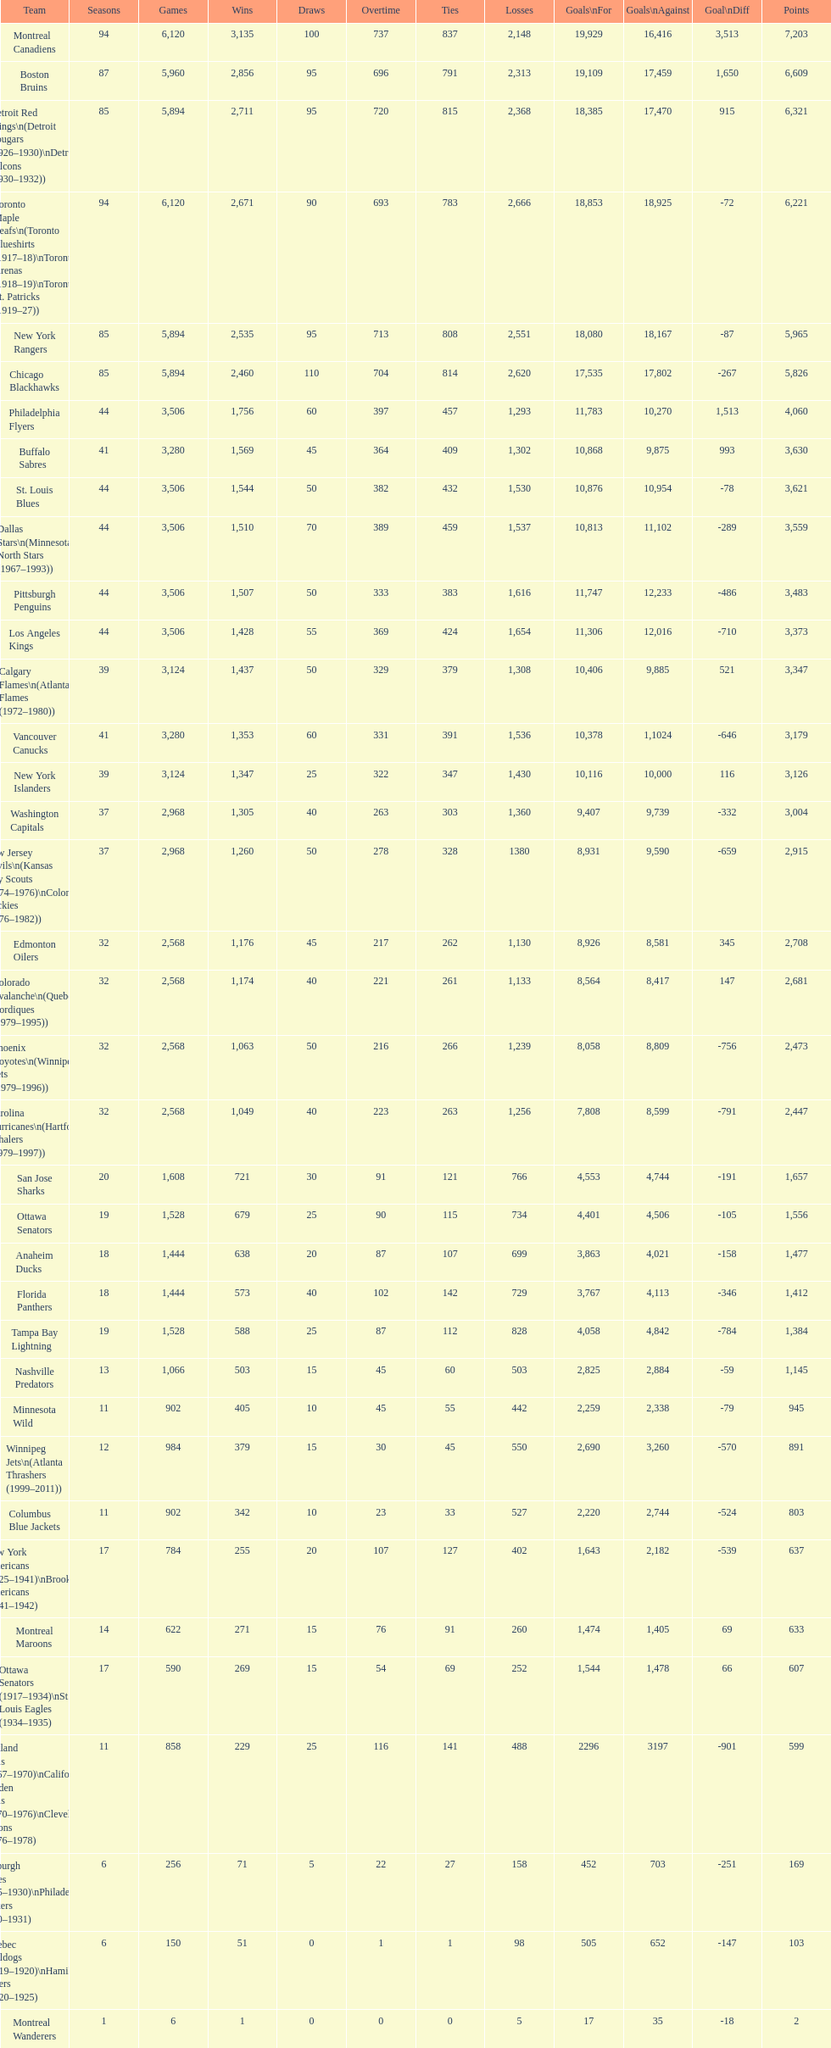How many losses do the st. louis blues have? 1,530. 